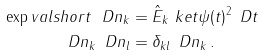Convert formula to latex. <formula><loc_0><loc_0><loc_500><loc_500>\exp v a l s h o r t { \ D n _ { k } } & = \| \hat { E } _ { k } \ k e t { \psi ( t ) } \| ^ { 2 } \, \ D t \\ \ D n _ { k } \, \ D n _ { l } & = \delta _ { k l } \, \ D n _ { k } \, .</formula> 